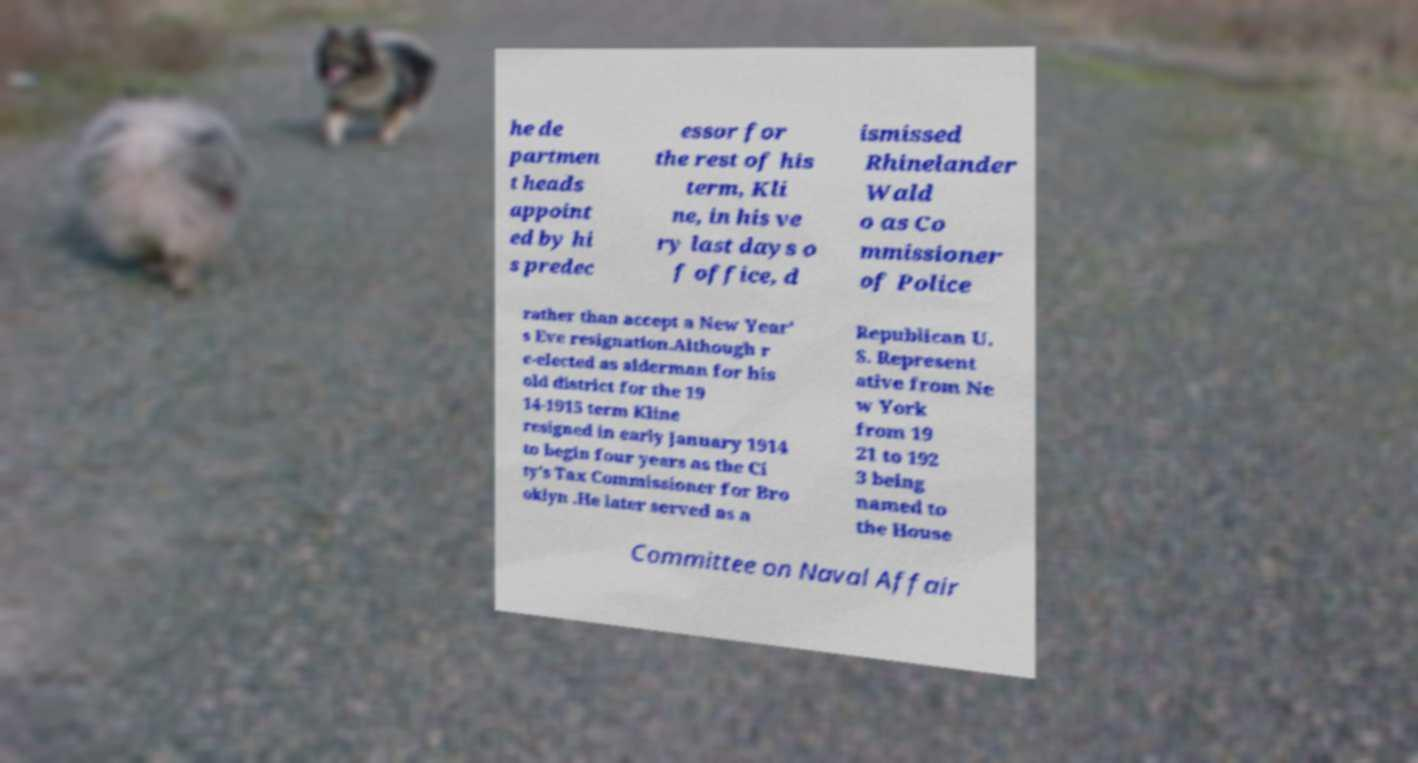Please read and relay the text visible in this image. What does it say? he de partmen t heads appoint ed by hi s predec essor for the rest of his term, Kli ne, in his ve ry last days o f office, d ismissed Rhinelander Wald o as Co mmissioner of Police rather than accept a New Year' s Eve resignation.Although r e-elected as alderman for his old district for the 19 14-1915 term Kline resigned in early January 1914 to begin four years as the Ci ty's Tax Commissioner for Bro oklyn .He later served as a Republican U. S. Represent ative from Ne w York from 19 21 to 192 3 being named to the House Committee on Naval Affair 